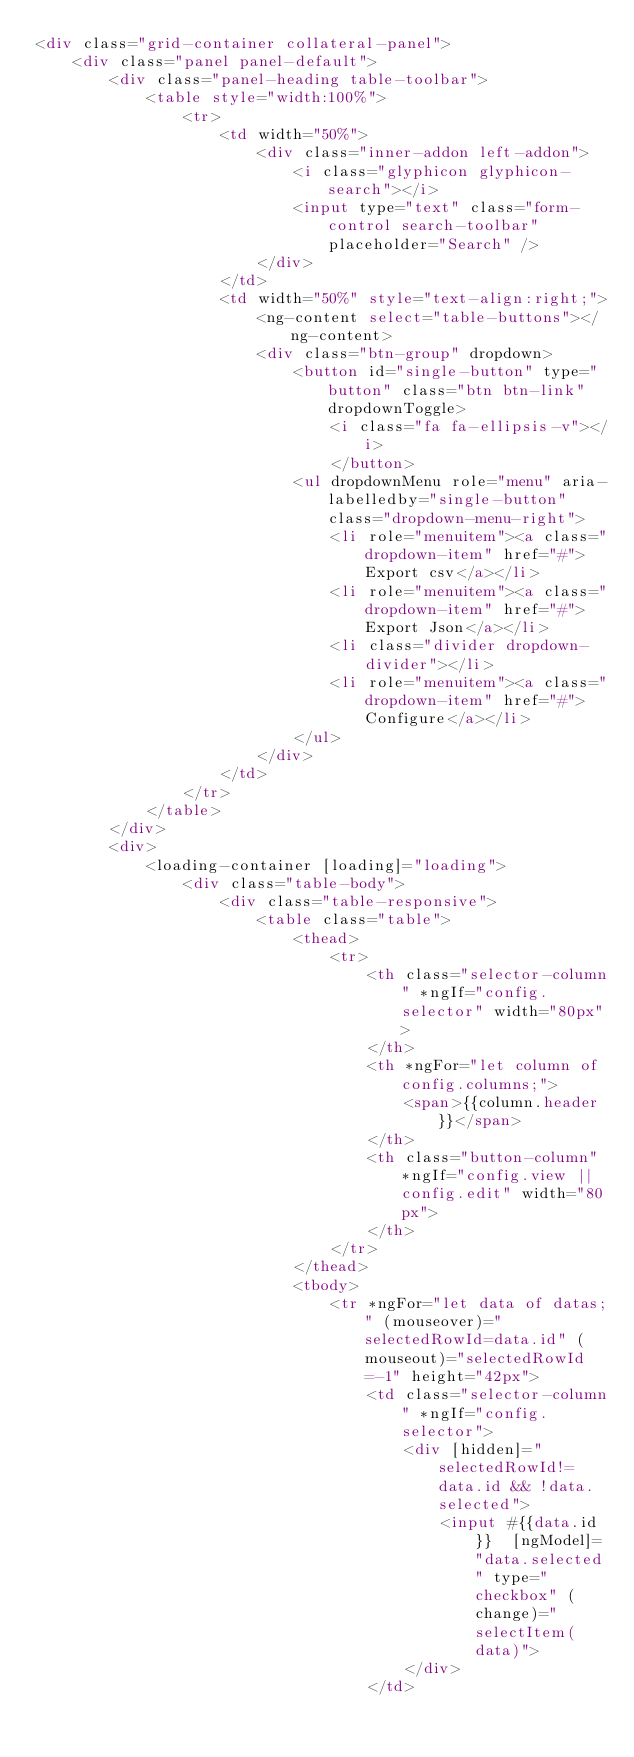Convert code to text. <code><loc_0><loc_0><loc_500><loc_500><_HTML_><div class="grid-container collateral-panel">
    <div class="panel panel-default">
        <div class="panel-heading table-toolbar">
            <table style="width:100%">
                <tr>
                    <td width="50%">
                        <div class="inner-addon left-addon">
                            <i class="glyphicon glyphicon-search"></i>
                            <input type="text" class="form-control search-toolbar" placeholder="Search" />
                        </div>
                    </td>
                    <td width="50%" style="text-align:right;">
                        <ng-content select="table-buttons"></ng-content>
                        <div class="btn-group" dropdown>
                            <button id="single-button" type="button" class="btn btn-link" dropdownToggle>
                                <i class="fa fa-ellipsis-v"></i>
                                </button>
                            <ul dropdownMenu role="menu" aria-labelledby="single-button" class="dropdown-menu-right">
                                <li role="menuitem"><a class="dropdown-item" href="#">Export csv</a></li>
                                <li role="menuitem"><a class="dropdown-item" href="#">Export Json</a></li>
                                <li class="divider dropdown-divider"></li>
                                <li role="menuitem"><a class="dropdown-item" href="#">Configure</a></li>
                            </ul>
                        </div>
                    </td>
                </tr>
            </table>
        </div>
        <div>
            <loading-container [loading]="loading">
                <div class="table-body">
                    <div class="table-responsive">
                        <table class="table">
                            <thead>
                                <tr>
                                    <th class="selector-column" *ngIf="config.selector" width="80px">
                                    </th>
                                    <th *ngFor="let column of config.columns;">
                                        <span>{{column.header}}</span>
                                    </th>
                                    <th class="button-column" *ngIf="config.view || config.edit" width="80px">
                                    </th>
                                </tr>
                            </thead>
                            <tbody>
                                <tr *ngFor="let data of datas;" (mouseover)="selectedRowId=data.id" (mouseout)="selectedRowId=-1" height="42px">
                                    <td class="selector-column" *ngIf="config.selector">
                                        <div [hidden]="selectedRowId!=data.id && !data.selected">
                                            <input #{{data.id}}  [ngModel]="data.selected" type="checkbox" (change)="selectItem(data)">
                                        </div>
                                    </td>                                    </code> 